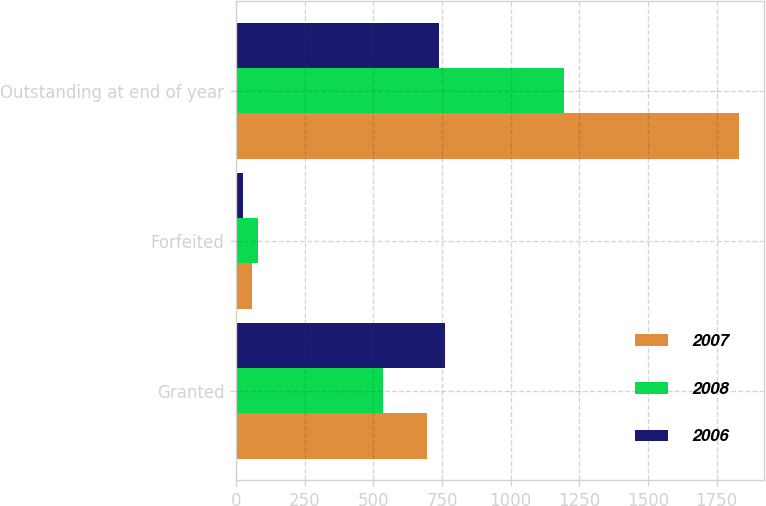Convert chart to OTSL. <chart><loc_0><loc_0><loc_500><loc_500><stacked_bar_chart><ecel><fcel>Granted<fcel>Forfeited<fcel>Outstanding at end of year<nl><fcel>2007<fcel>696<fcel>60<fcel>1830<nl><fcel>2008<fcel>537<fcel>81<fcel>1194<nl><fcel>2006<fcel>762<fcel>24<fcel>738<nl></chart> 